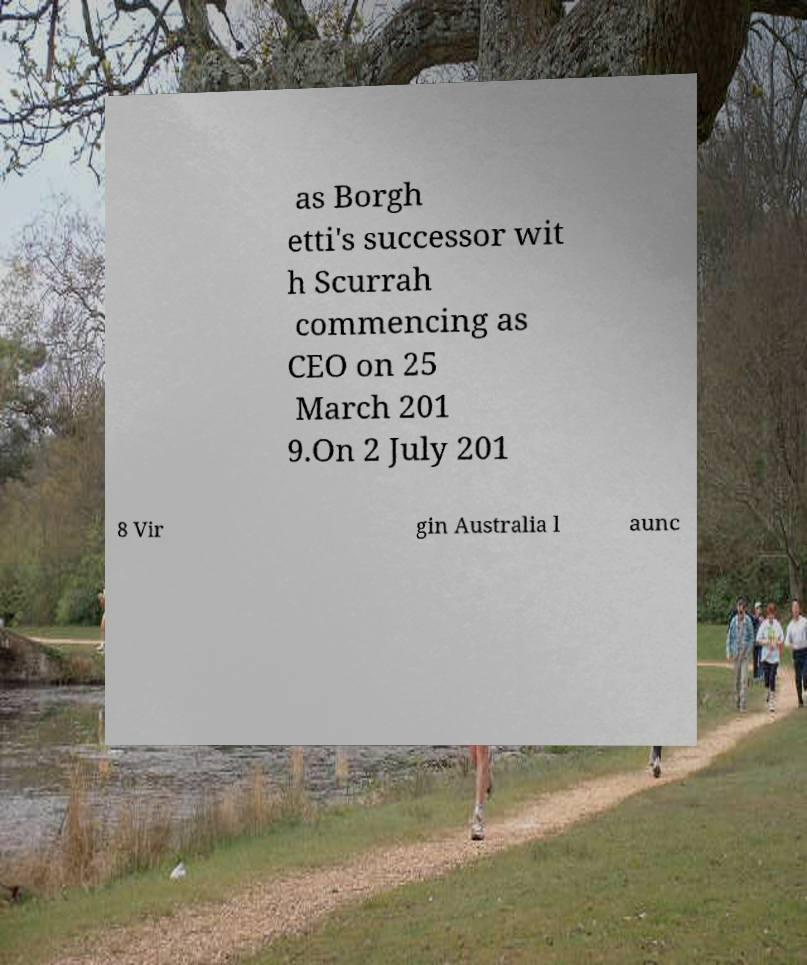Can you accurately transcribe the text from the provided image for me? as Borgh etti's successor wit h Scurrah commencing as CEO on 25 March 201 9.On 2 July 201 8 Vir gin Australia l aunc 